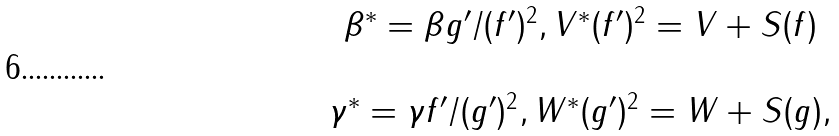<formula> <loc_0><loc_0><loc_500><loc_500>\begin{array} { c } \beta ^ { * } = \beta g ^ { \prime } / ( f ^ { \prime } ) ^ { 2 } , V ^ { * } ( f ^ { \prime } ) ^ { 2 } = V + S ( f ) \\ \ \\ \gamma ^ { * } = \gamma f ^ { \prime } / ( g ^ { \prime } ) ^ { 2 } , W ^ { * } ( g ^ { \prime } ) ^ { 2 } = W + S ( g ) , \end{array}</formula> 